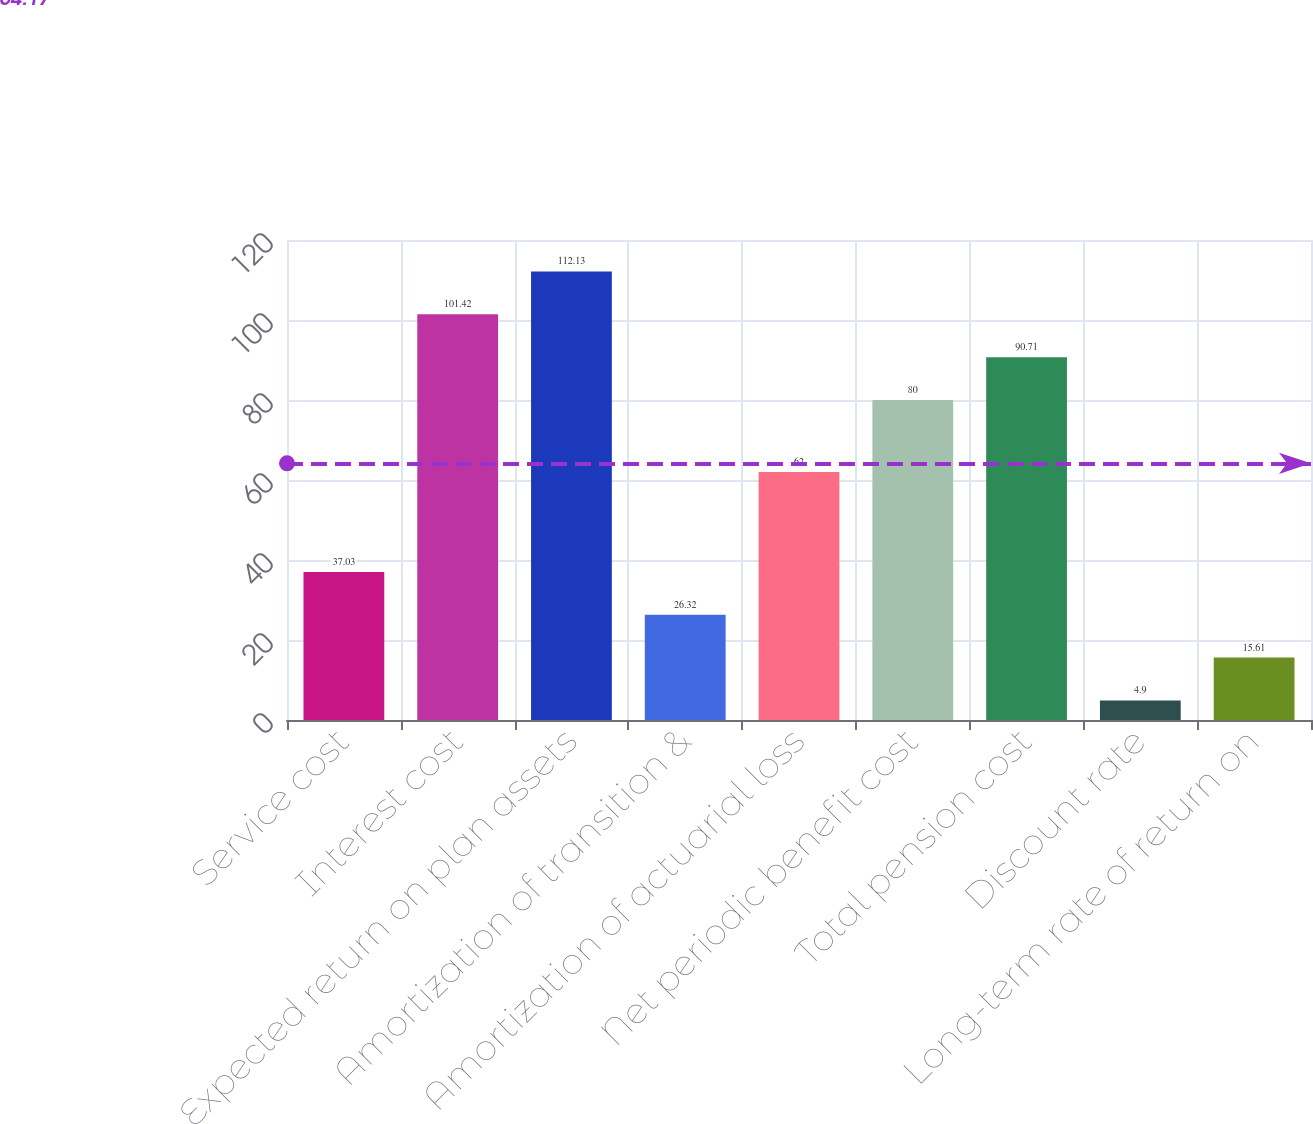Convert chart to OTSL. <chart><loc_0><loc_0><loc_500><loc_500><bar_chart><fcel>Service cost<fcel>Interest cost<fcel>Expected return on plan assets<fcel>Amortization of transition &<fcel>Amortization of actuarial loss<fcel>Net periodic benefit cost<fcel>Total pension cost<fcel>Discount rate<fcel>Long-term rate of return on<nl><fcel>37.03<fcel>101.42<fcel>112.13<fcel>26.32<fcel>62<fcel>80<fcel>90.71<fcel>4.9<fcel>15.61<nl></chart> 